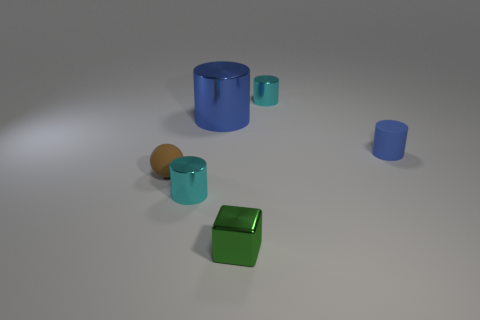The metallic cylinder that is the same color as the tiny rubber cylinder is what size?
Make the answer very short. Large. How many gray things are either tiny things or small shiny things?
Provide a short and direct response. 0. There is a blue thing that is the same size as the green shiny thing; what material is it?
Provide a succinct answer. Rubber. What is the shape of the small shiny thing that is in front of the rubber cylinder and behind the small green shiny cube?
Make the answer very short. Cylinder. What color is the matte ball that is the same size as the shiny block?
Your response must be concise. Brown. Does the cyan cylinder behind the tiny blue matte object have the same size as the blue thing on the left side of the small blue matte thing?
Give a very brief answer. No. There is a thing left of the tiny cyan shiny cylinder that is to the left of the small metal object that is behind the blue shiny object; what size is it?
Make the answer very short. Small. What is the shape of the object that is in front of the cyan thing left of the metal block?
Offer a very short reply. Cube. Do the cylinder in front of the small matte sphere and the tiny rubber sphere have the same color?
Make the answer very short. No. What is the color of the cylinder that is both to the left of the matte cylinder and right of the tiny green block?
Your answer should be very brief. Cyan. 